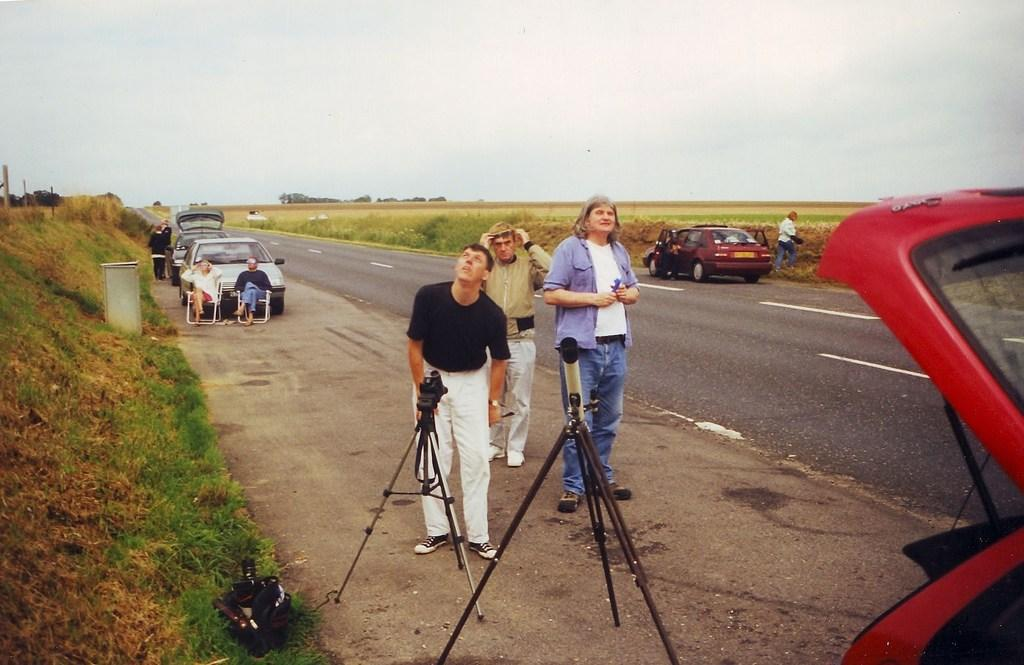Where was the image taken? The image is clicked outside. What can be seen at the top of the image? The sky is visible at the top of the image. What is located in the middle of the image? There are cars and people standing in the middle of the image. What is present in the front of the image? There are two strands in the front of the image. What type of knowledge is being shared by the secretary in the image? There is no secretary present in the image, so no knowledge can be shared. 